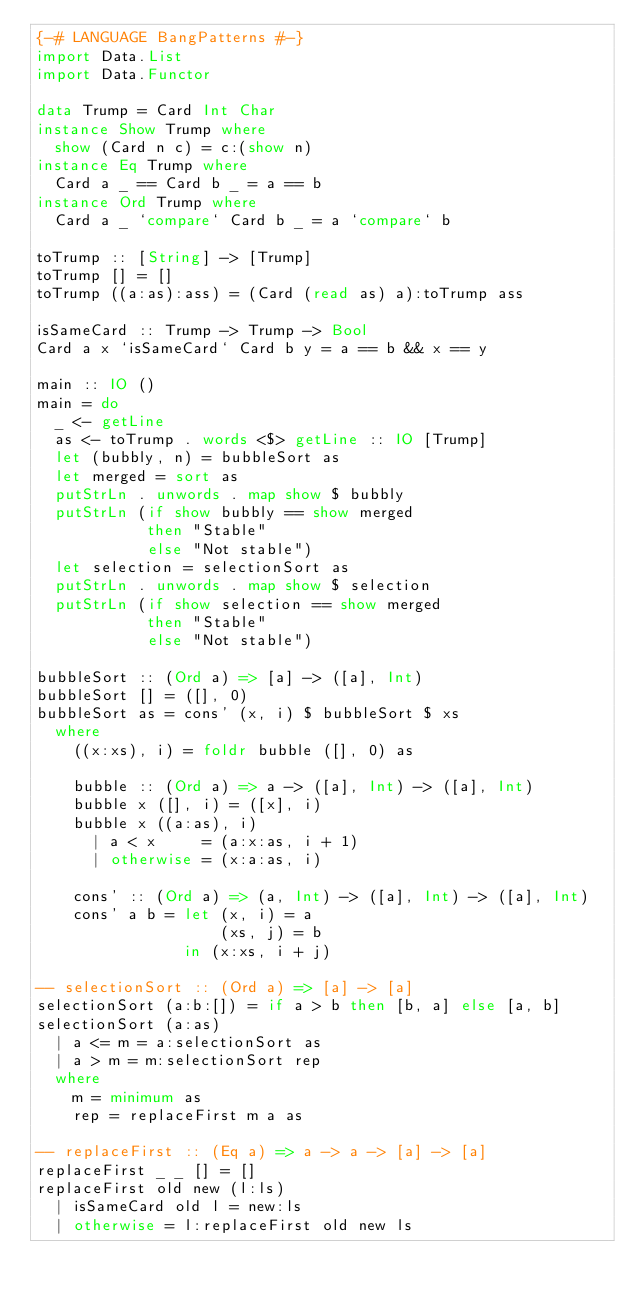Convert code to text. <code><loc_0><loc_0><loc_500><loc_500><_Haskell_>{-# LANGUAGE BangPatterns #-}
import Data.List
import Data.Functor

data Trump = Card Int Char
instance Show Trump where
  show (Card n c) = c:(show n)
instance Eq Trump where
  Card a _ == Card b _ = a == b
instance Ord Trump where
  Card a _ `compare` Card b _ = a `compare` b

toTrump :: [String] -> [Trump]
toTrump [] = []
toTrump ((a:as):ass) = (Card (read as) a):toTrump ass

isSameCard :: Trump -> Trump -> Bool
Card a x `isSameCard` Card b y = a == b && x == y

main :: IO ()
main = do
  _ <- getLine
  as <- toTrump . words <$> getLine :: IO [Trump]
  let (bubbly, n) = bubbleSort as
  let merged = sort as
  putStrLn . unwords . map show $ bubbly
  putStrLn (if show bubbly == show merged
            then "Stable"
            else "Not stable")
  let selection = selectionSort as
  putStrLn . unwords . map show $ selection
  putStrLn (if show selection == show merged
            then "Stable"
            else "Not stable")

bubbleSort :: (Ord a) => [a] -> ([a], Int)
bubbleSort [] = ([], 0)
bubbleSort as = cons' (x, i) $ bubbleSort $ xs
  where
    ((x:xs), i) = foldr bubble ([], 0) as

    bubble :: (Ord a) => a -> ([a], Int) -> ([a], Int)
    bubble x ([], i) = ([x], i)
    bubble x ((a:as), i)
      | a < x     = (a:x:as, i + 1)
      | otherwise = (x:a:as, i)

    cons' :: (Ord a) => (a, Int) -> ([a], Int) -> ([a], Int)
    cons' a b = let (x, i) = a
                    (xs, j) = b
                in (x:xs, i + j)

-- selectionSort :: (Ord a) => [a] -> [a]
selectionSort (a:b:[]) = if a > b then [b, a] else [a, b]
selectionSort (a:as)
  | a <= m = a:selectionSort as
  | a > m = m:selectionSort rep
  where
    m = minimum as
    rep = replaceFirst m a as

-- replaceFirst :: (Eq a) => a -> a -> [a] -> [a]
replaceFirst _ _ [] = []
replaceFirst old new (l:ls)
  | isSameCard old l = new:ls
  | otherwise = l:replaceFirst old new ls

</code> 